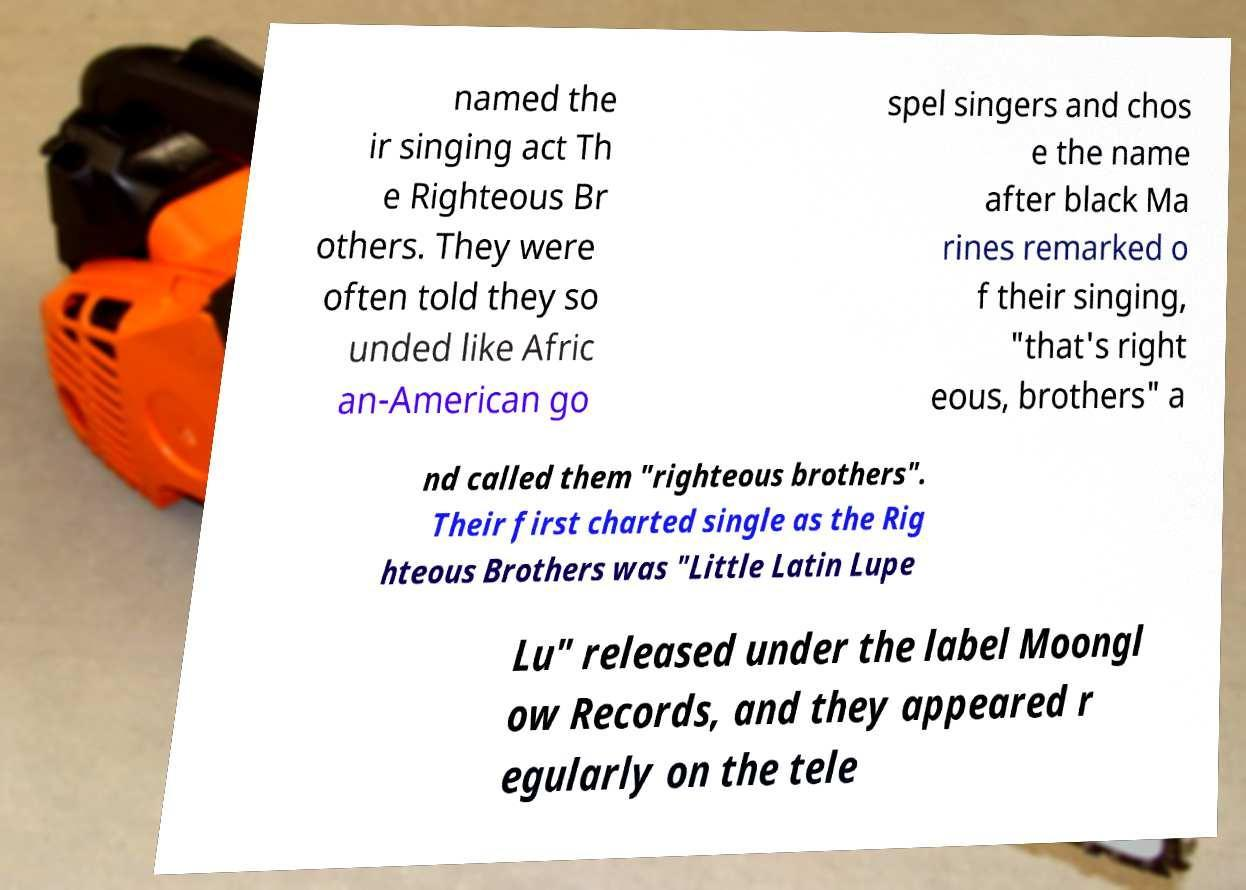Can you accurately transcribe the text from the provided image for me? named the ir singing act Th e Righteous Br others. They were often told they so unded like Afric an-American go spel singers and chos e the name after black Ma rines remarked o f their singing, "that's right eous, brothers" a nd called them "righteous brothers". Their first charted single as the Rig hteous Brothers was "Little Latin Lupe Lu" released under the label Moongl ow Records, and they appeared r egularly on the tele 